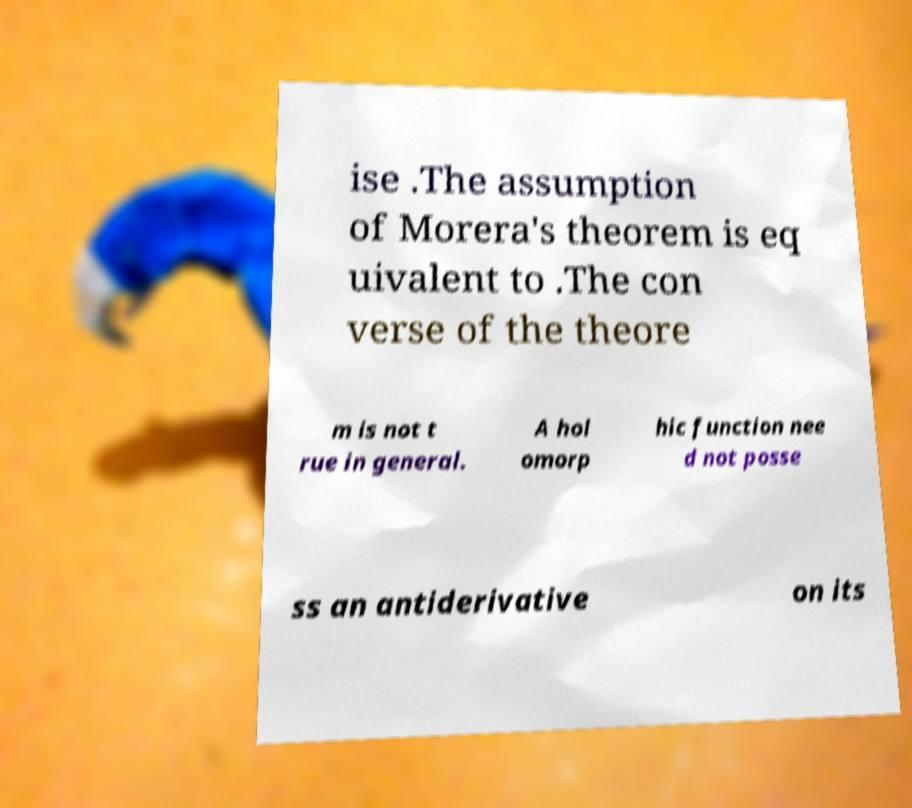Can you accurately transcribe the text from the provided image for me? ise .The assumption of Morera's theorem is eq uivalent to .The con verse of the theore m is not t rue in general. A hol omorp hic function nee d not posse ss an antiderivative on its 